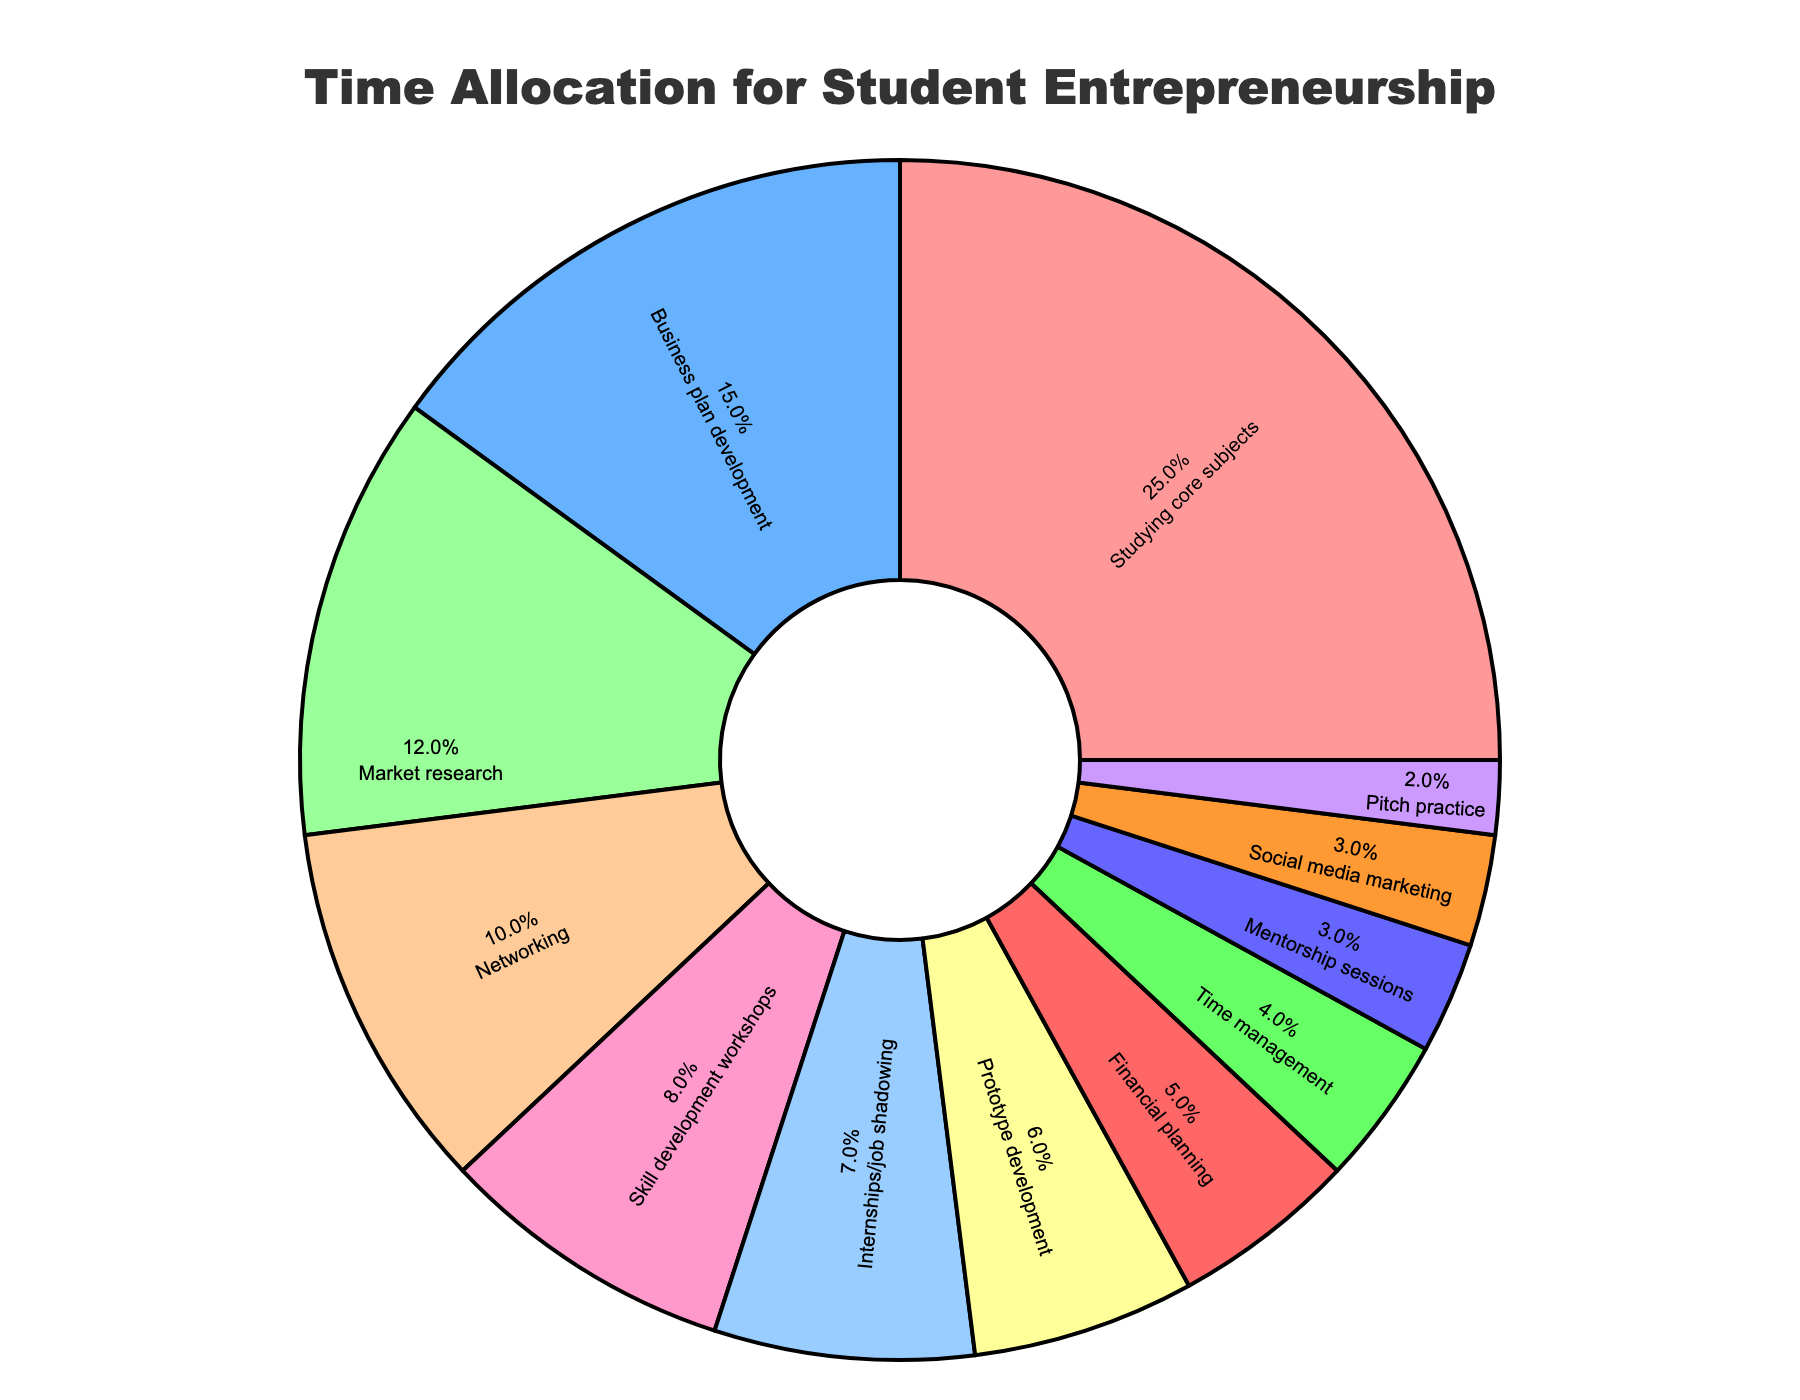What is the largest time allocation category? By observing the pie chart, the largest segment corresponds to "Studying core subjects" with the highest percentage.
Answer: Studying core subjects Which category has a higher percentage, Market research or Skill development workshops? By comparing the slices corresponding to "Market research" (12%) and "Skill development workshops" (8%), it's evident that Market research has a higher percentage.
Answer: Market research How much more time is spent on Business plan development compared to Mentorship sessions? The percentage for "Business plan development" is 15%, while for "Mentorship sessions" it is 3%. Subtracting these gives 15% - 3% = 12%.
Answer: 12% What categories share the same percentage of time allocation, if any? By observing the percentages, "Social media marketing" and "Mentorship sessions" both have 3%.
Answer: Social media marketing, Mentorship sessions What is the total percentage of time allocated to Prototype development and Financial planning? Prototype development is 6%, and Financial planning is 5%. Adding these gives 6% + 5% = 11%.
Answer: 11% How many categories allocate 5% or less of the total time? The categories are "Financial planning" (5%), "Time management" (4%), "Mentorship sessions" (3%), "Social media marketing" (3%), and "Pitch practice" (2%). Counting these gives 5 categories.
Answer: 5 Which categories combined make up more than 50% of the time allocation? Summing the top categories until the sum exceeds 50%: "Studying core subjects" (25%), "Business plan development" (15%), and "Market research" (12%) combine to 25% + 15% + 12% = 52%.
Answer: Studying core subjects, Business plan development, Market research Are there more categories with time allocation above or below 10%? Count categories above 10%: Studying core subjects (25%), Business plan development (15%), Market research (12%) are 3 categories. Below 10%: Networking (10%), Skill development workshops (8%), Internships/job shadowing (7%), Prototype development (6%), Financial planning (5%), Time management (4%), Mentorship sessions (3%), Social media marketing (3%), Pitch practice (2%) are 9 categories.
Answer: Below 10% Which activity is represented by the light blue color in the chart? The category label inside the light blue colored slice corresponds to “Market research” with a percentage of 12%.
Answer: Market research 